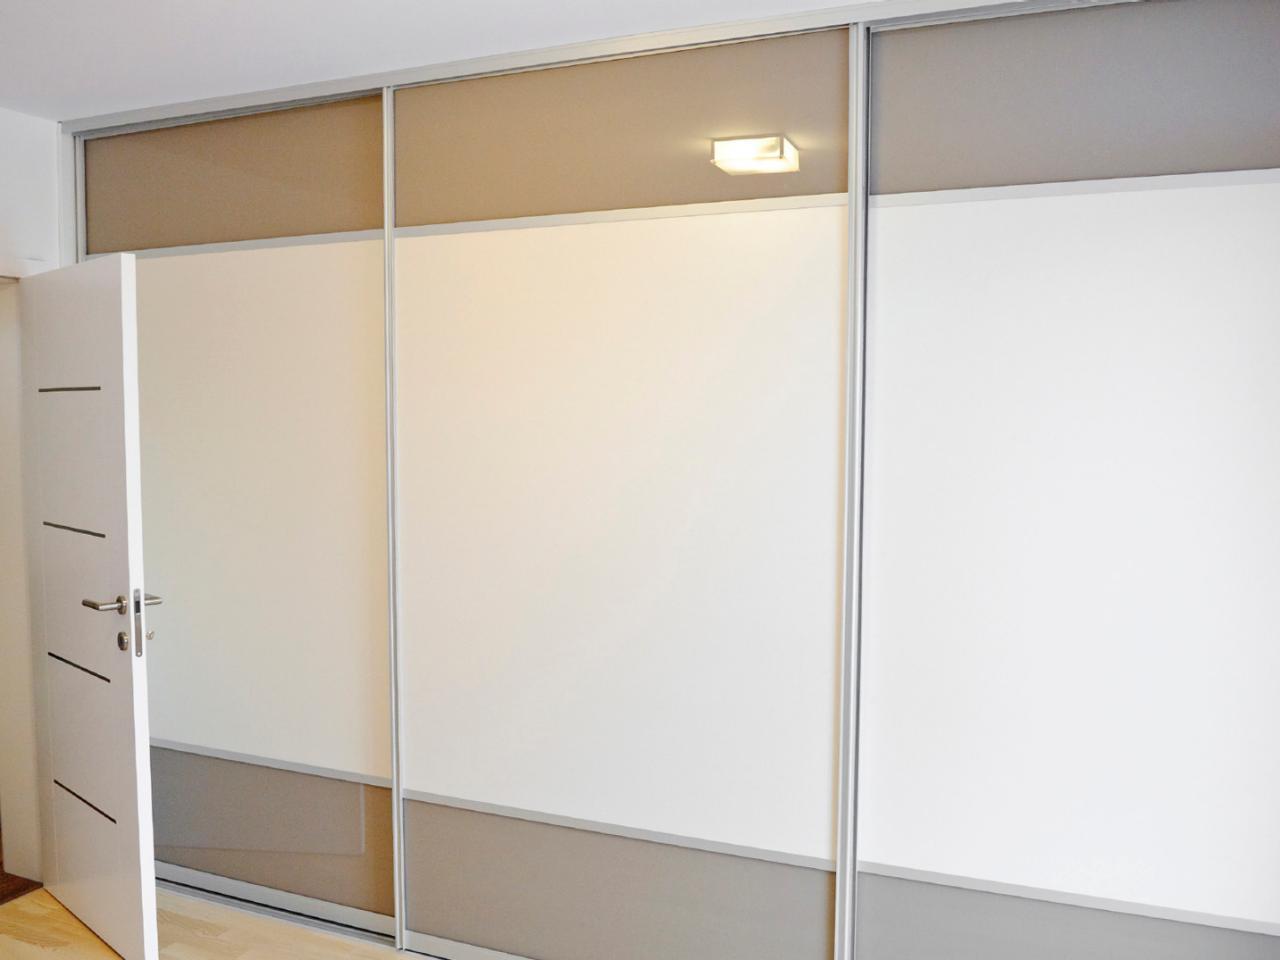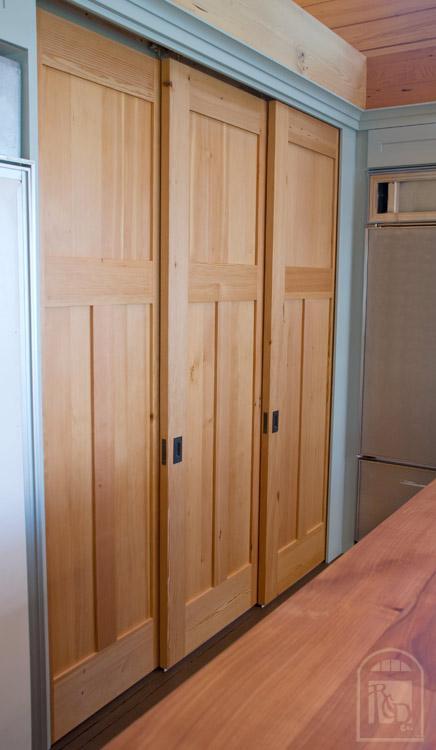The first image is the image on the left, the second image is the image on the right. Assess this claim about the two images: "In one image, a tan wood three-panel door has square inlays at the top and two long rectangles at the bottom.". Correct or not? Answer yes or no. Yes. The first image is the image on the left, the second image is the image on the right. Assess this claim about the two images: "An image shows triple wooden sliding doors topped with molding trim.". Correct or not? Answer yes or no. Yes. 